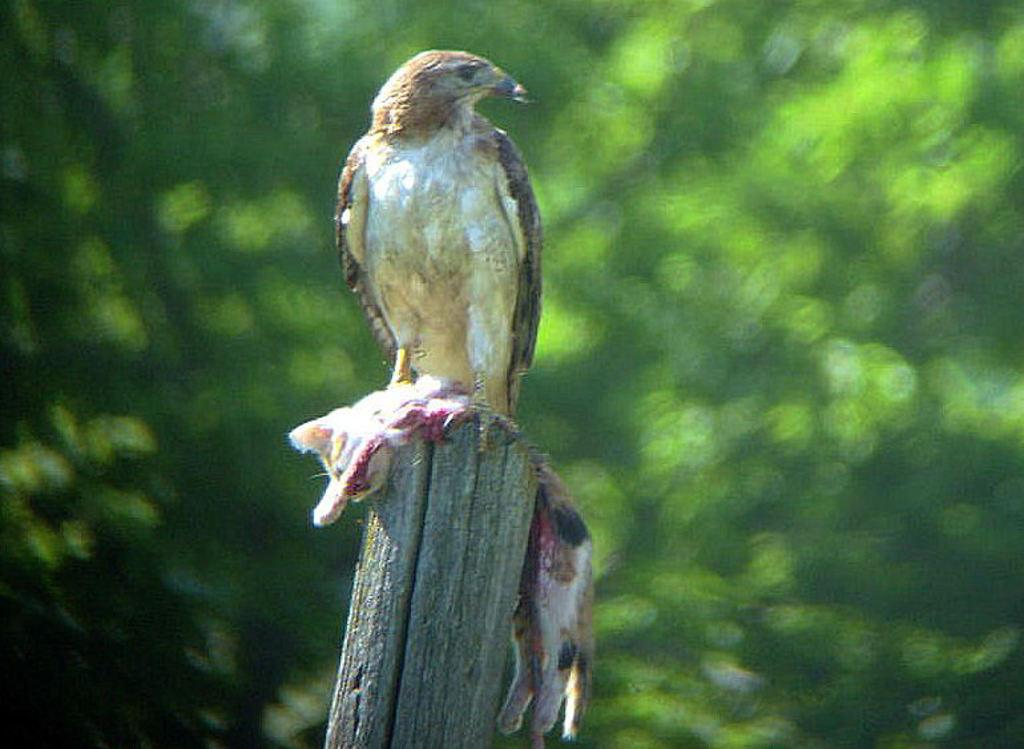What is located in the foreground of the image? There is a pole in the foreground of the image. What animals are on the pole? A cat's body and an eagle are on the pole. What can be seen in the background of the image? There is greenery in the background of the image. What is the tendency of the dad in the image? There is no dad present in the image, so it is not possible to determine any tendencies. 